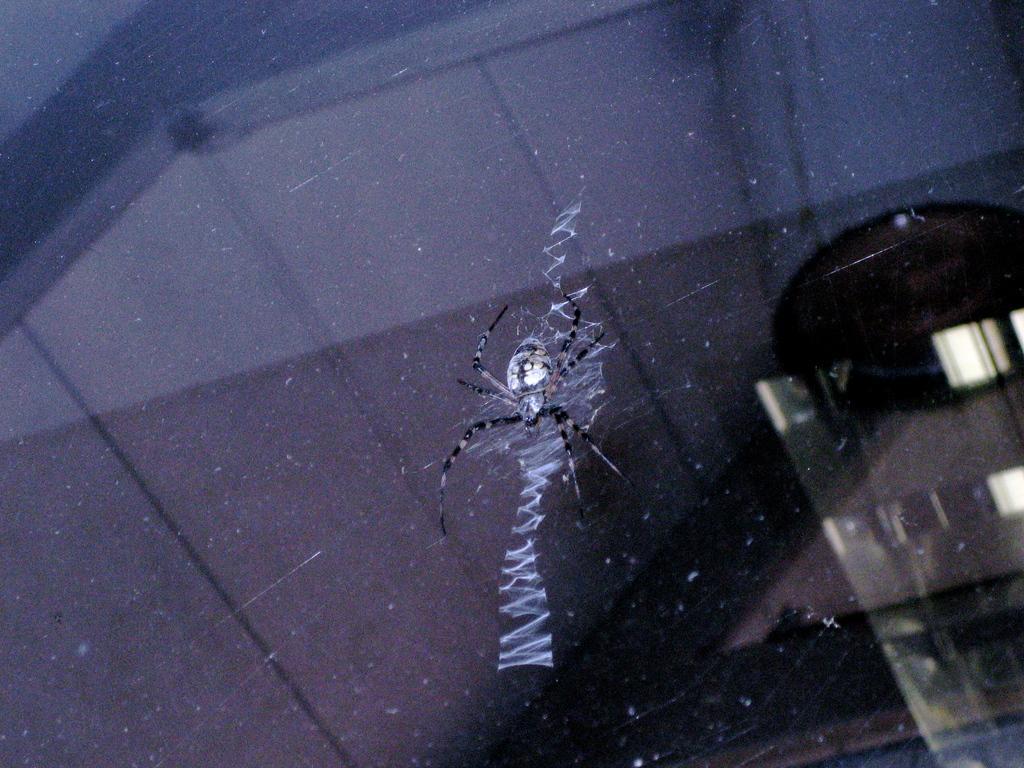Could you give a brief overview of what you see in this image? In this images I can see a spider on a glass. 